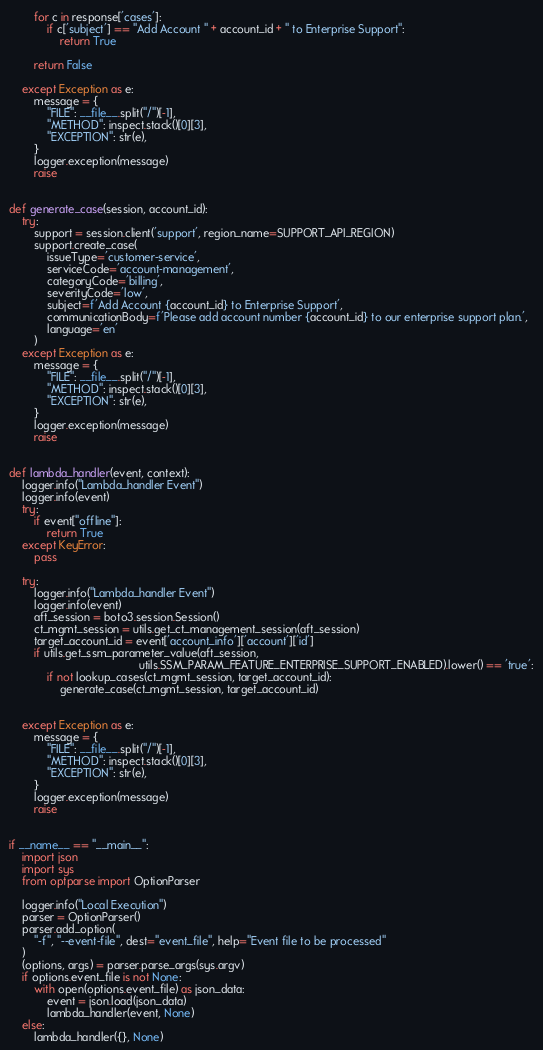<code> <loc_0><loc_0><loc_500><loc_500><_Python_>        for c in response['cases']:
            if c['subject'] == "Add Account " + account_id + " to Enterprise Support":
                return True

        return False

    except Exception as e:
        message = {
            "FILE": __file__.split("/")[-1],
            "METHOD": inspect.stack()[0][3],
            "EXCEPTION": str(e),
        }
        logger.exception(message)
        raise


def generate_case(session, account_id):
    try:
        support = session.client('support', region_name=SUPPORT_API_REGION)
        support.create_case(
            issueType='customer-service',
            serviceCode='account-management',
            categoryCode='billing',
            severityCode='low',
            subject=f'Add Account {account_id} to Enterprise Support',
            communicationBody=f'Please add account number {account_id} to our enterprise support plan.',
            language='en'
        )
    except Exception as e:
        message = {
            "FILE": __file__.split("/")[-1],
            "METHOD": inspect.stack()[0][3],
            "EXCEPTION": str(e),
        }
        logger.exception(message)
        raise


def lambda_handler(event, context):
    logger.info("Lambda_handler Event")
    logger.info(event)
    try:
        if event["offline"]:
            return True
    except KeyError:
        pass

    try:
        logger.info("Lambda_handler Event")
        logger.info(event)
        aft_session = boto3.session.Session()
        ct_mgmt_session = utils.get_ct_management_session(aft_session)
        target_account_id = event['account_info']['account']['id']
        if utils.get_ssm_parameter_value(aft_session,
                                         utils.SSM_PARAM_FEATURE_ENTERPRISE_SUPPORT_ENABLED).lower() == 'true':
            if not lookup_cases(ct_mgmt_session, target_account_id):
                generate_case(ct_mgmt_session, target_account_id)


    except Exception as e:
        message = {
            "FILE": __file__.split("/")[-1],
            "METHOD": inspect.stack()[0][3],
            "EXCEPTION": str(e),
        }
        logger.exception(message)
        raise


if __name__ == "__main__":
    import json
    import sys
    from optparse import OptionParser

    logger.info("Local Execution")
    parser = OptionParser()
    parser.add_option(
        "-f", "--event-file", dest="event_file", help="Event file to be processed"
    )
    (options, args) = parser.parse_args(sys.argv)
    if options.event_file is not None:
        with open(options.event_file) as json_data:
            event = json.load(json_data)
            lambda_handler(event, None)
    else:
        lambda_handler({}, None)
</code> 